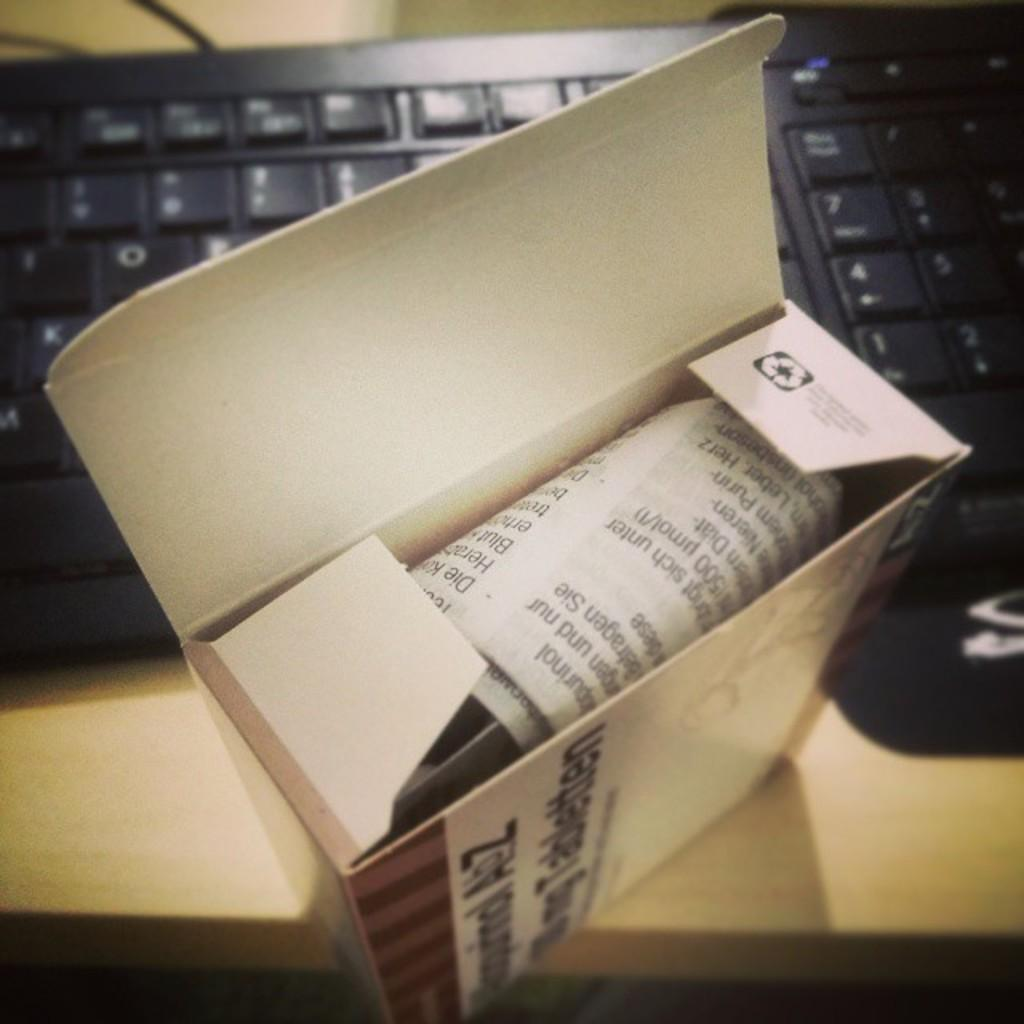<image>
Describe the image concisely. A box for Tabletten is open in front of a keyboard. 